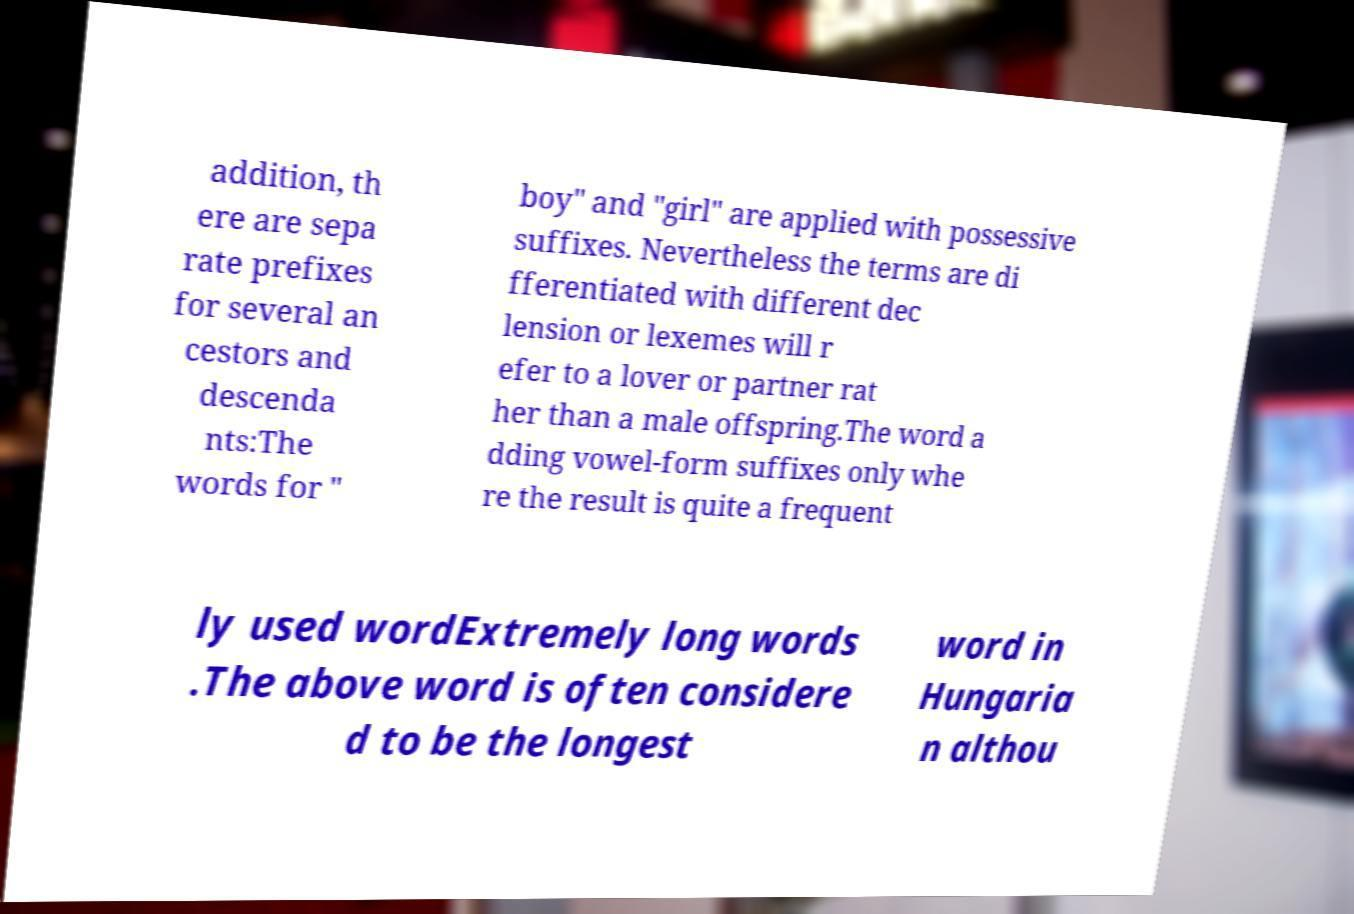There's text embedded in this image that I need extracted. Can you transcribe it verbatim? addition, th ere are sepa rate prefixes for several an cestors and descenda nts:The words for " boy" and "girl" are applied with possessive suffixes. Nevertheless the terms are di fferentiated with different dec lension or lexemes will r efer to a lover or partner rat her than a male offspring.The word a dding vowel-form suffixes only whe re the result is quite a frequent ly used wordExtremely long words .The above word is often considere d to be the longest word in Hungaria n althou 